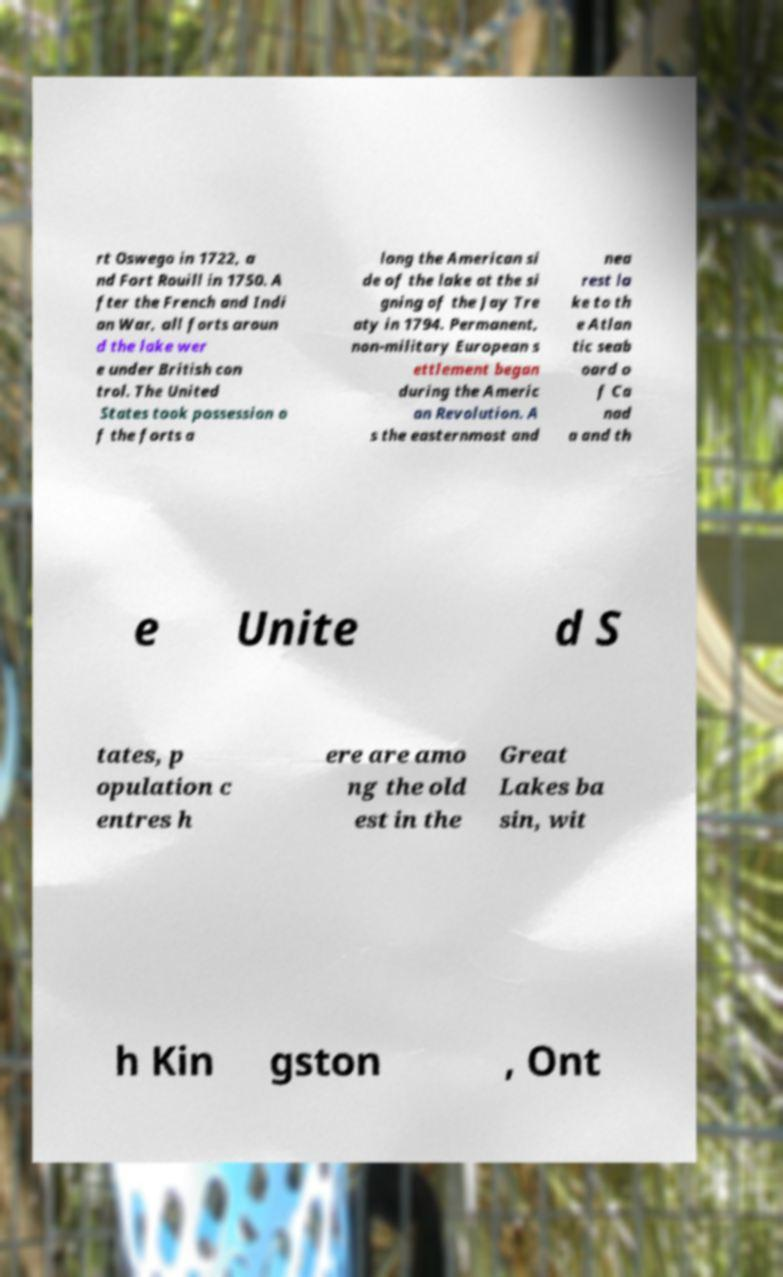Can you accurately transcribe the text from the provided image for me? rt Oswego in 1722, a nd Fort Rouill in 1750. A fter the French and Indi an War, all forts aroun d the lake wer e under British con trol. The United States took possession o f the forts a long the American si de of the lake at the si gning of the Jay Tre aty in 1794. Permanent, non-military European s ettlement began during the Americ an Revolution. A s the easternmost and nea rest la ke to th e Atlan tic seab oard o f Ca nad a and th e Unite d S tates, p opulation c entres h ere are amo ng the old est in the Great Lakes ba sin, wit h Kin gston , Ont 